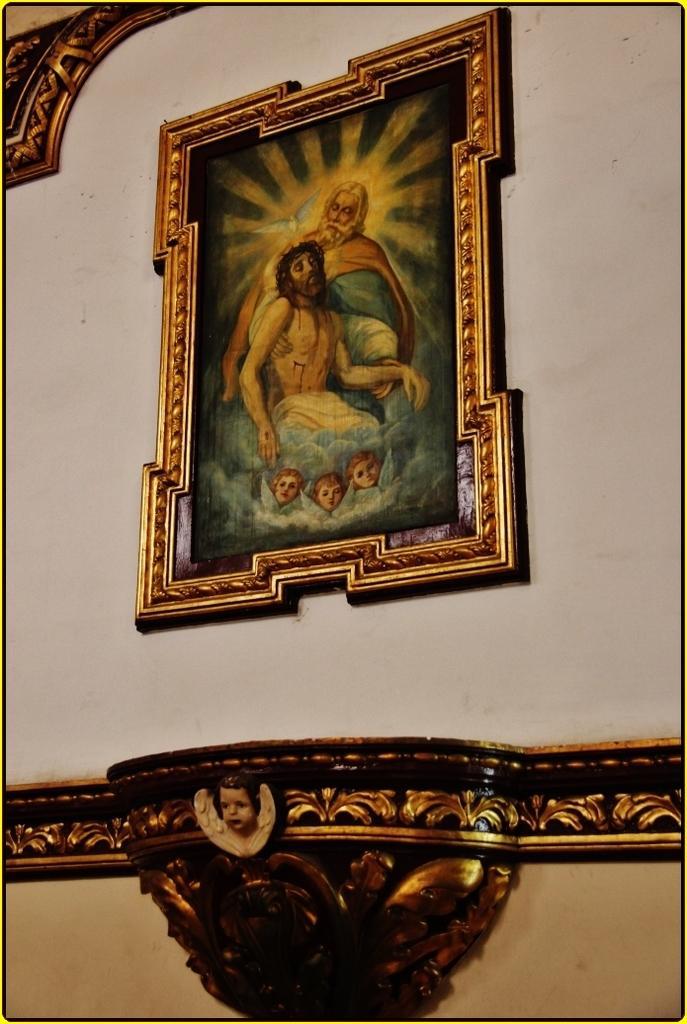In one or two sentences, can you explain what this image depicts? In this image I can see white color wall and on it I can see a painting in golden color frame. Here I can see a face of a child. 